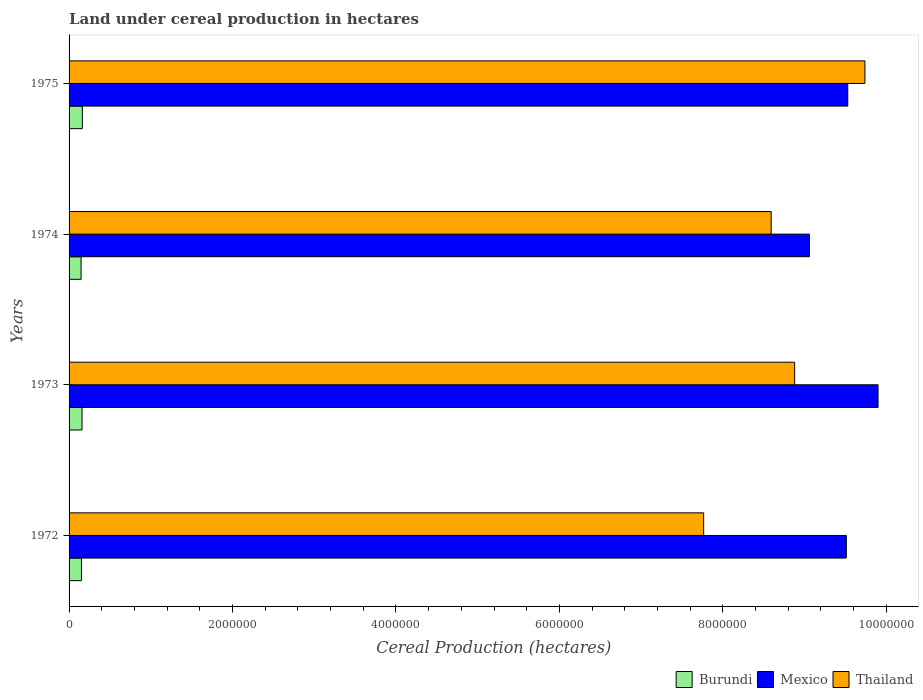How many groups of bars are there?
Offer a terse response. 4. Are the number of bars on each tick of the Y-axis equal?
Your answer should be compact. Yes. How many bars are there on the 1st tick from the top?
Offer a very short reply. 3. How many bars are there on the 2nd tick from the bottom?
Keep it short and to the point. 3. What is the label of the 2nd group of bars from the top?
Provide a short and direct response. 1974. What is the land under cereal production in Burundi in 1972?
Your response must be concise. 1.52e+05. Across all years, what is the maximum land under cereal production in Thailand?
Make the answer very short. 9.74e+06. Across all years, what is the minimum land under cereal production in Burundi?
Offer a terse response. 1.47e+05. In which year was the land under cereal production in Thailand maximum?
Provide a short and direct response. 1975. In which year was the land under cereal production in Burundi minimum?
Your response must be concise. 1974. What is the total land under cereal production in Thailand in the graph?
Keep it short and to the point. 3.50e+07. What is the difference between the land under cereal production in Burundi in 1972 and that in 1974?
Offer a very short reply. 4793. What is the difference between the land under cereal production in Mexico in 1972 and the land under cereal production in Thailand in 1974?
Ensure brevity in your answer.  9.19e+05. What is the average land under cereal production in Thailand per year?
Make the answer very short. 8.74e+06. In the year 1975, what is the difference between the land under cereal production in Burundi and land under cereal production in Thailand?
Your response must be concise. -9.58e+06. In how many years, is the land under cereal production in Burundi greater than 800000 hectares?
Your answer should be very brief. 0. What is the ratio of the land under cereal production in Thailand in 1972 to that in 1974?
Offer a very short reply. 0.9. Is the land under cereal production in Burundi in 1974 less than that in 1975?
Your response must be concise. Yes. What is the difference between the highest and the second highest land under cereal production in Mexico?
Your response must be concise. 3.71e+05. What is the difference between the highest and the lowest land under cereal production in Thailand?
Your answer should be very brief. 1.97e+06. What does the 1st bar from the top in 1973 represents?
Provide a short and direct response. Thailand. What does the 3rd bar from the bottom in 1975 represents?
Your answer should be very brief. Thailand. How many bars are there?
Ensure brevity in your answer.  12. Are all the bars in the graph horizontal?
Keep it short and to the point. Yes. How many years are there in the graph?
Keep it short and to the point. 4. Are the values on the major ticks of X-axis written in scientific E-notation?
Your answer should be compact. No. Does the graph contain any zero values?
Your answer should be compact. No. How are the legend labels stacked?
Provide a succinct answer. Horizontal. What is the title of the graph?
Offer a terse response. Land under cereal production in hectares. Does "Armenia" appear as one of the legend labels in the graph?
Make the answer very short. No. What is the label or title of the X-axis?
Your answer should be compact. Cereal Production (hectares). What is the Cereal Production (hectares) in Burundi in 1972?
Your response must be concise. 1.52e+05. What is the Cereal Production (hectares) of Mexico in 1972?
Offer a very short reply. 9.51e+06. What is the Cereal Production (hectares) in Thailand in 1972?
Provide a succinct answer. 7.76e+06. What is the Cereal Production (hectares) in Burundi in 1973?
Provide a short and direct response. 1.58e+05. What is the Cereal Production (hectares) in Mexico in 1973?
Provide a short and direct response. 9.90e+06. What is the Cereal Production (hectares) in Thailand in 1973?
Your answer should be compact. 8.88e+06. What is the Cereal Production (hectares) in Burundi in 1974?
Provide a short and direct response. 1.47e+05. What is the Cereal Production (hectares) of Mexico in 1974?
Your answer should be compact. 9.06e+06. What is the Cereal Production (hectares) of Thailand in 1974?
Your answer should be compact. 8.59e+06. What is the Cereal Production (hectares) of Burundi in 1975?
Keep it short and to the point. 1.62e+05. What is the Cereal Production (hectares) of Mexico in 1975?
Ensure brevity in your answer.  9.53e+06. What is the Cereal Production (hectares) of Thailand in 1975?
Offer a very short reply. 9.74e+06. Across all years, what is the maximum Cereal Production (hectares) of Burundi?
Your answer should be very brief. 1.62e+05. Across all years, what is the maximum Cereal Production (hectares) of Mexico?
Make the answer very short. 9.90e+06. Across all years, what is the maximum Cereal Production (hectares) in Thailand?
Ensure brevity in your answer.  9.74e+06. Across all years, what is the minimum Cereal Production (hectares) of Burundi?
Offer a terse response. 1.47e+05. Across all years, what is the minimum Cereal Production (hectares) of Mexico?
Make the answer very short. 9.06e+06. Across all years, what is the minimum Cereal Production (hectares) of Thailand?
Keep it short and to the point. 7.76e+06. What is the total Cereal Production (hectares) of Burundi in the graph?
Your answer should be very brief. 6.20e+05. What is the total Cereal Production (hectares) of Mexico in the graph?
Provide a short and direct response. 3.80e+07. What is the total Cereal Production (hectares) in Thailand in the graph?
Ensure brevity in your answer.  3.50e+07. What is the difference between the Cereal Production (hectares) of Burundi in 1972 and that in 1973?
Your answer should be very brief. -6675. What is the difference between the Cereal Production (hectares) of Mexico in 1972 and that in 1973?
Offer a terse response. -3.88e+05. What is the difference between the Cereal Production (hectares) of Thailand in 1972 and that in 1973?
Ensure brevity in your answer.  -1.11e+06. What is the difference between the Cereal Production (hectares) of Burundi in 1972 and that in 1974?
Your response must be concise. 4793. What is the difference between the Cereal Production (hectares) in Mexico in 1972 and that in 1974?
Your response must be concise. 4.51e+05. What is the difference between the Cereal Production (hectares) of Thailand in 1972 and that in 1974?
Your answer should be compact. -8.26e+05. What is the difference between the Cereal Production (hectares) of Burundi in 1972 and that in 1975?
Provide a short and direct response. -1.07e+04. What is the difference between the Cereal Production (hectares) in Mexico in 1972 and that in 1975?
Your answer should be very brief. -1.78e+04. What is the difference between the Cereal Production (hectares) of Thailand in 1972 and that in 1975?
Ensure brevity in your answer.  -1.97e+06. What is the difference between the Cereal Production (hectares) of Burundi in 1973 and that in 1974?
Your response must be concise. 1.15e+04. What is the difference between the Cereal Production (hectares) of Mexico in 1973 and that in 1974?
Provide a short and direct response. 8.40e+05. What is the difference between the Cereal Production (hectares) in Thailand in 1973 and that in 1974?
Offer a terse response. 2.87e+05. What is the difference between the Cereal Production (hectares) in Burundi in 1973 and that in 1975?
Your answer should be compact. -4070. What is the difference between the Cereal Production (hectares) of Mexico in 1973 and that in 1975?
Provide a succinct answer. 3.71e+05. What is the difference between the Cereal Production (hectares) of Thailand in 1973 and that in 1975?
Offer a very short reply. -8.60e+05. What is the difference between the Cereal Production (hectares) of Burundi in 1974 and that in 1975?
Provide a short and direct response. -1.55e+04. What is the difference between the Cereal Production (hectares) of Mexico in 1974 and that in 1975?
Give a very brief answer. -4.69e+05. What is the difference between the Cereal Production (hectares) in Thailand in 1974 and that in 1975?
Provide a succinct answer. -1.15e+06. What is the difference between the Cereal Production (hectares) of Burundi in 1972 and the Cereal Production (hectares) of Mexico in 1973?
Offer a terse response. -9.75e+06. What is the difference between the Cereal Production (hectares) in Burundi in 1972 and the Cereal Production (hectares) in Thailand in 1973?
Offer a very short reply. -8.73e+06. What is the difference between the Cereal Production (hectares) in Mexico in 1972 and the Cereal Production (hectares) in Thailand in 1973?
Provide a succinct answer. 6.32e+05. What is the difference between the Cereal Production (hectares) of Burundi in 1972 and the Cereal Production (hectares) of Mexico in 1974?
Your answer should be very brief. -8.91e+06. What is the difference between the Cereal Production (hectares) in Burundi in 1972 and the Cereal Production (hectares) in Thailand in 1974?
Offer a terse response. -8.44e+06. What is the difference between the Cereal Production (hectares) of Mexico in 1972 and the Cereal Production (hectares) of Thailand in 1974?
Give a very brief answer. 9.19e+05. What is the difference between the Cereal Production (hectares) in Burundi in 1972 and the Cereal Production (hectares) in Mexico in 1975?
Your response must be concise. -9.38e+06. What is the difference between the Cereal Production (hectares) of Burundi in 1972 and the Cereal Production (hectares) of Thailand in 1975?
Make the answer very short. -9.59e+06. What is the difference between the Cereal Production (hectares) in Mexico in 1972 and the Cereal Production (hectares) in Thailand in 1975?
Offer a very short reply. -2.28e+05. What is the difference between the Cereal Production (hectares) of Burundi in 1973 and the Cereal Production (hectares) of Mexico in 1974?
Keep it short and to the point. -8.90e+06. What is the difference between the Cereal Production (hectares) of Burundi in 1973 and the Cereal Production (hectares) of Thailand in 1974?
Offer a terse response. -8.43e+06. What is the difference between the Cereal Production (hectares) of Mexico in 1973 and the Cereal Production (hectares) of Thailand in 1974?
Offer a very short reply. 1.31e+06. What is the difference between the Cereal Production (hectares) in Burundi in 1973 and the Cereal Production (hectares) in Mexico in 1975?
Give a very brief answer. -9.37e+06. What is the difference between the Cereal Production (hectares) in Burundi in 1973 and the Cereal Production (hectares) in Thailand in 1975?
Offer a terse response. -9.58e+06. What is the difference between the Cereal Production (hectares) of Mexico in 1973 and the Cereal Production (hectares) of Thailand in 1975?
Offer a terse response. 1.61e+05. What is the difference between the Cereal Production (hectares) of Burundi in 1974 and the Cereal Production (hectares) of Mexico in 1975?
Your answer should be compact. -9.38e+06. What is the difference between the Cereal Production (hectares) of Burundi in 1974 and the Cereal Production (hectares) of Thailand in 1975?
Provide a short and direct response. -9.59e+06. What is the difference between the Cereal Production (hectares) of Mexico in 1974 and the Cereal Production (hectares) of Thailand in 1975?
Make the answer very short. -6.79e+05. What is the average Cereal Production (hectares) in Burundi per year?
Your answer should be compact. 1.55e+05. What is the average Cereal Production (hectares) in Mexico per year?
Keep it short and to the point. 9.50e+06. What is the average Cereal Production (hectares) in Thailand per year?
Offer a very short reply. 8.74e+06. In the year 1972, what is the difference between the Cereal Production (hectares) of Burundi and Cereal Production (hectares) of Mexico?
Your response must be concise. -9.36e+06. In the year 1972, what is the difference between the Cereal Production (hectares) in Burundi and Cereal Production (hectares) in Thailand?
Provide a short and direct response. -7.61e+06. In the year 1972, what is the difference between the Cereal Production (hectares) in Mexico and Cereal Production (hectares) in Thailand?
Keep it short and to the point. 1.75e+06. In the year 1973, what is the difference between the Cereal Production (hectares) in Burundi and Cereal Production (hectares) in Mexico?
Your answer should be very brief. -9.74e+06. In the year 1973, what is the difference between the Cereal Production (hectares) of Burundi and Cereal Production (hectares) of Thailand?
Offer a terse response. -8.72e+06. In the year 1973, what is the difference between the Cereal Production (hectares) of Mexico and Cereal Production (hectares) of Thailand?
Make the answer very short. 1.02e+06. In the year 1974, what is the difference between the Cereal Production (hectares) in Burundi and Cereal Production (hectares) in Mexico?
Your answer should be very brief. -8.91e+06. In the year 1974, what is the difference between the Cereal Production (hectares) of Burundi and Cereal Production (hectares) of Thailand?
Give a very brief answer. -8.44e+06. In the year 1974, what is the difference between the Cereal Production (hectares) of Mexico and Cereal Production (hectares) of Thailand?
Provide a succinct answer. 4.68e+05. In the year 1975, what is the difference between the Cereal Production (hectares) of Burundi and Cereal Production (hectares) of Mexico?
Your response must be concise. -9.37e+06. In the year 1975, what is the difference between the Cereal Production (hectares) of Burundi and Cereal Production (hectares) of Thailand?
Make the answer very short. -9.58e+06. In the year 1975, what is the difference between the Cereal Production (hectares) of Mexico and Cereal Production (hectares) of Thailand?
Offer a terse response. -2.10e+05. What is the ratio of the Cereal Production (hectares) in Burundi in 1972 to that in 1973?
Offer a terse response. 0.96. What is the ratio of the Cereal Production (hectares) in Mexico in 1972 to that in 1973?
Your response must be concise. 0.96. What is the ratio of the Cereal Production (hectares) in Thailand in 1972 to that in 1973?
Give a very brief answer. 0.87. What is the ratio of the Cereal Production (hectares) in Burundi in 1972 to that in 1974?
Ensure brevity in your answer.  1.03. What is the ratio of the Cereal Production (hectares) of Mexico in 1972 to that in 1974?
Your response must be concise. 1.05. What is the ratio of the Cereal Production (hectares) in Thailand in 1972 to that in 1974?
Give a very brief answer. 0.9. What is the ratio of the Cereal Production (hectares) of Burundi in 1972 to that in 1975?
Your answer should be compact. 0.93. What is the ratio of the Cereal Production (hectares) in Thailand in 1972 to that in 1975?
Your response must be concise. 0.8. What is the ratio of the Cereal Production (hectares) in Burundi in 1973 to that in 1974?
Keep it short and to the point. 1.08. What is the ratio of the Cereal Production (hectares) in Mexico in 1973 to that in 1974?
Keep it short and to the point. 1.09. What is the ratio of the Cereal Production (hectares) in Thailand in 1973 to that in 1974?
Your answer should be compact. 1.03. What is the ratio of the Cereal Production (hectares) in Burundi in 1973 to that in 1975?
Keep it short and to the point. 0.97. What is the ratio of the Cereal Production (hectares) of Mexico in 1973 to that in 1975?
Your response must be concise. 1.04. What is the ratio of the Cereal Production (hectares) in Thailand in 1973 to that in 1975?
Provide a short and direct response. 0.91. What is the ratio of the Cereal Production (hectares) of Burundi in 1974 to that in 1975?
Your answer should be compact. 0.9. What is the ratio of the Cereal Production (hectares) in Mexico in 1974 to that in 1975?
Keep it short and to the point. 0.95. What is the ratio of the Cereal Production (hectares) in Thailand in 1974 to that in 1975?
Give a very brief answer. 0.88. What is the difference between the highest and the second highest Cereal Production (hectares) of Burundi?
Provide a succinct answer. 4070. What is the difference between the highest and the second highest Cereal Production (hectares) in Mexico?
Ensure brevity in your answer.  3.71e+05. What is the difference between the highest and the second highest Cereal Production (hectares) in Thailand?
Offer a terse response. 8.60e+05. What is the difference between the highest and the lowest Cereal Production (hectares) in Burundi?
Provide a succinct answer. 1.55e+04. What is the difference between the highest and the lowest Cereal Production (hectares) in Mexico?
Your answer should be very brief. 8.40e+05. What is the difference between the highest and the lowest Cereal Production (hectares) of Thailand?
Your response must be concise. 1.97e+06. 